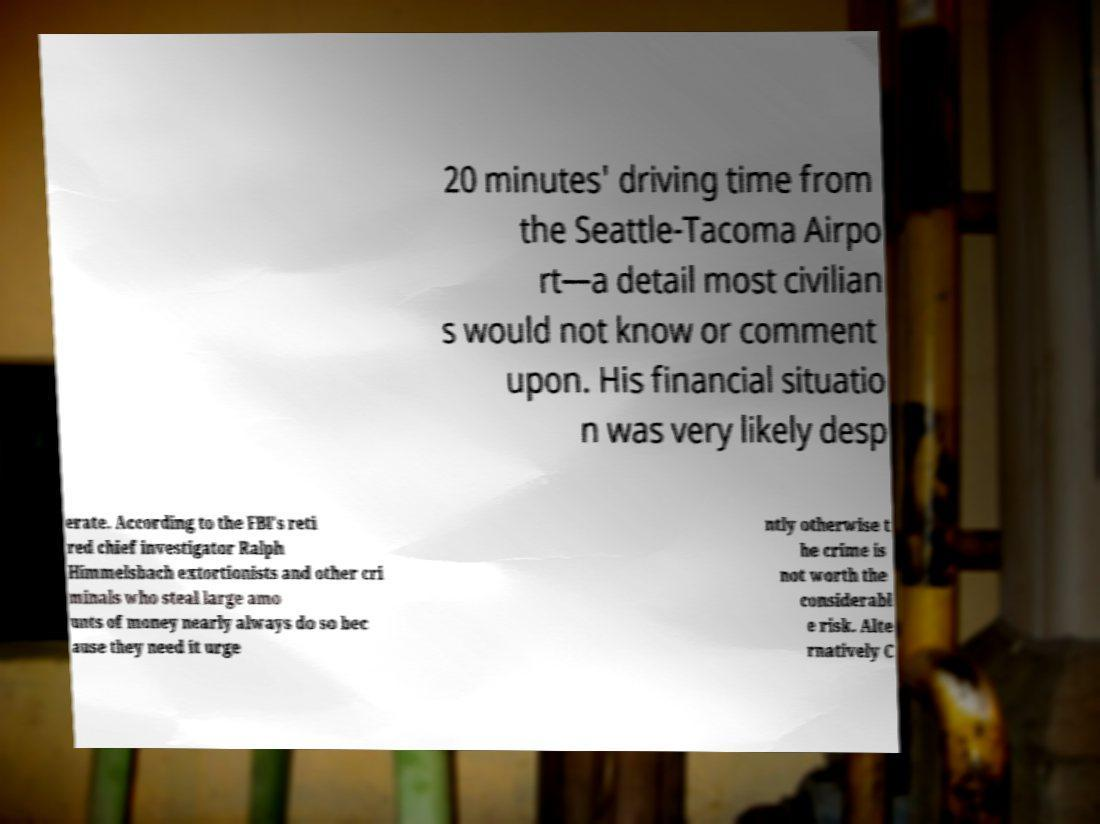What messages or text are displayed in this image? I need them in a readable, typed format. 20 minutes' driving time from the Seattle-Tacoma Airpo rt—a detail most civilian s would not know or comment upon. His financial situatio n was very likely desp erate. According to the FBI's reti red chief investigator Ralph Himmelsbach extortionists and other cri minals who steal large amo unts of money nearly always do so bec ause they need it urge ntly otherwise t he crime is not worth the considerabl e risk. Alte rnatively C 